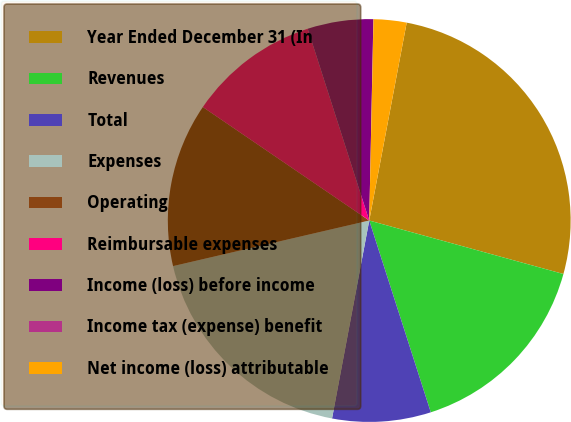Convert chart to OTSL. <chart><loc_0><loc_0><loc_500><loc_500><pie_chart><fcel>Year Ended December 31 (In<fcel>Revenues<fcel>Total<fcel>Expenses<fcel>Operating<fcel>Reimbursable expenses<fcel>Income (loss) before income<fcel>Income tax (expense) benefit<fcel>Net income (loss) attributable<nl><fcel>26.3%<fcel>15.78%<fcel>7.9%<fcel>18.41%<fcel>13.16%<fcel>10.53%<fcel>5.27%<fcel>0.01%<fcel>2.64%<nl></chart> 